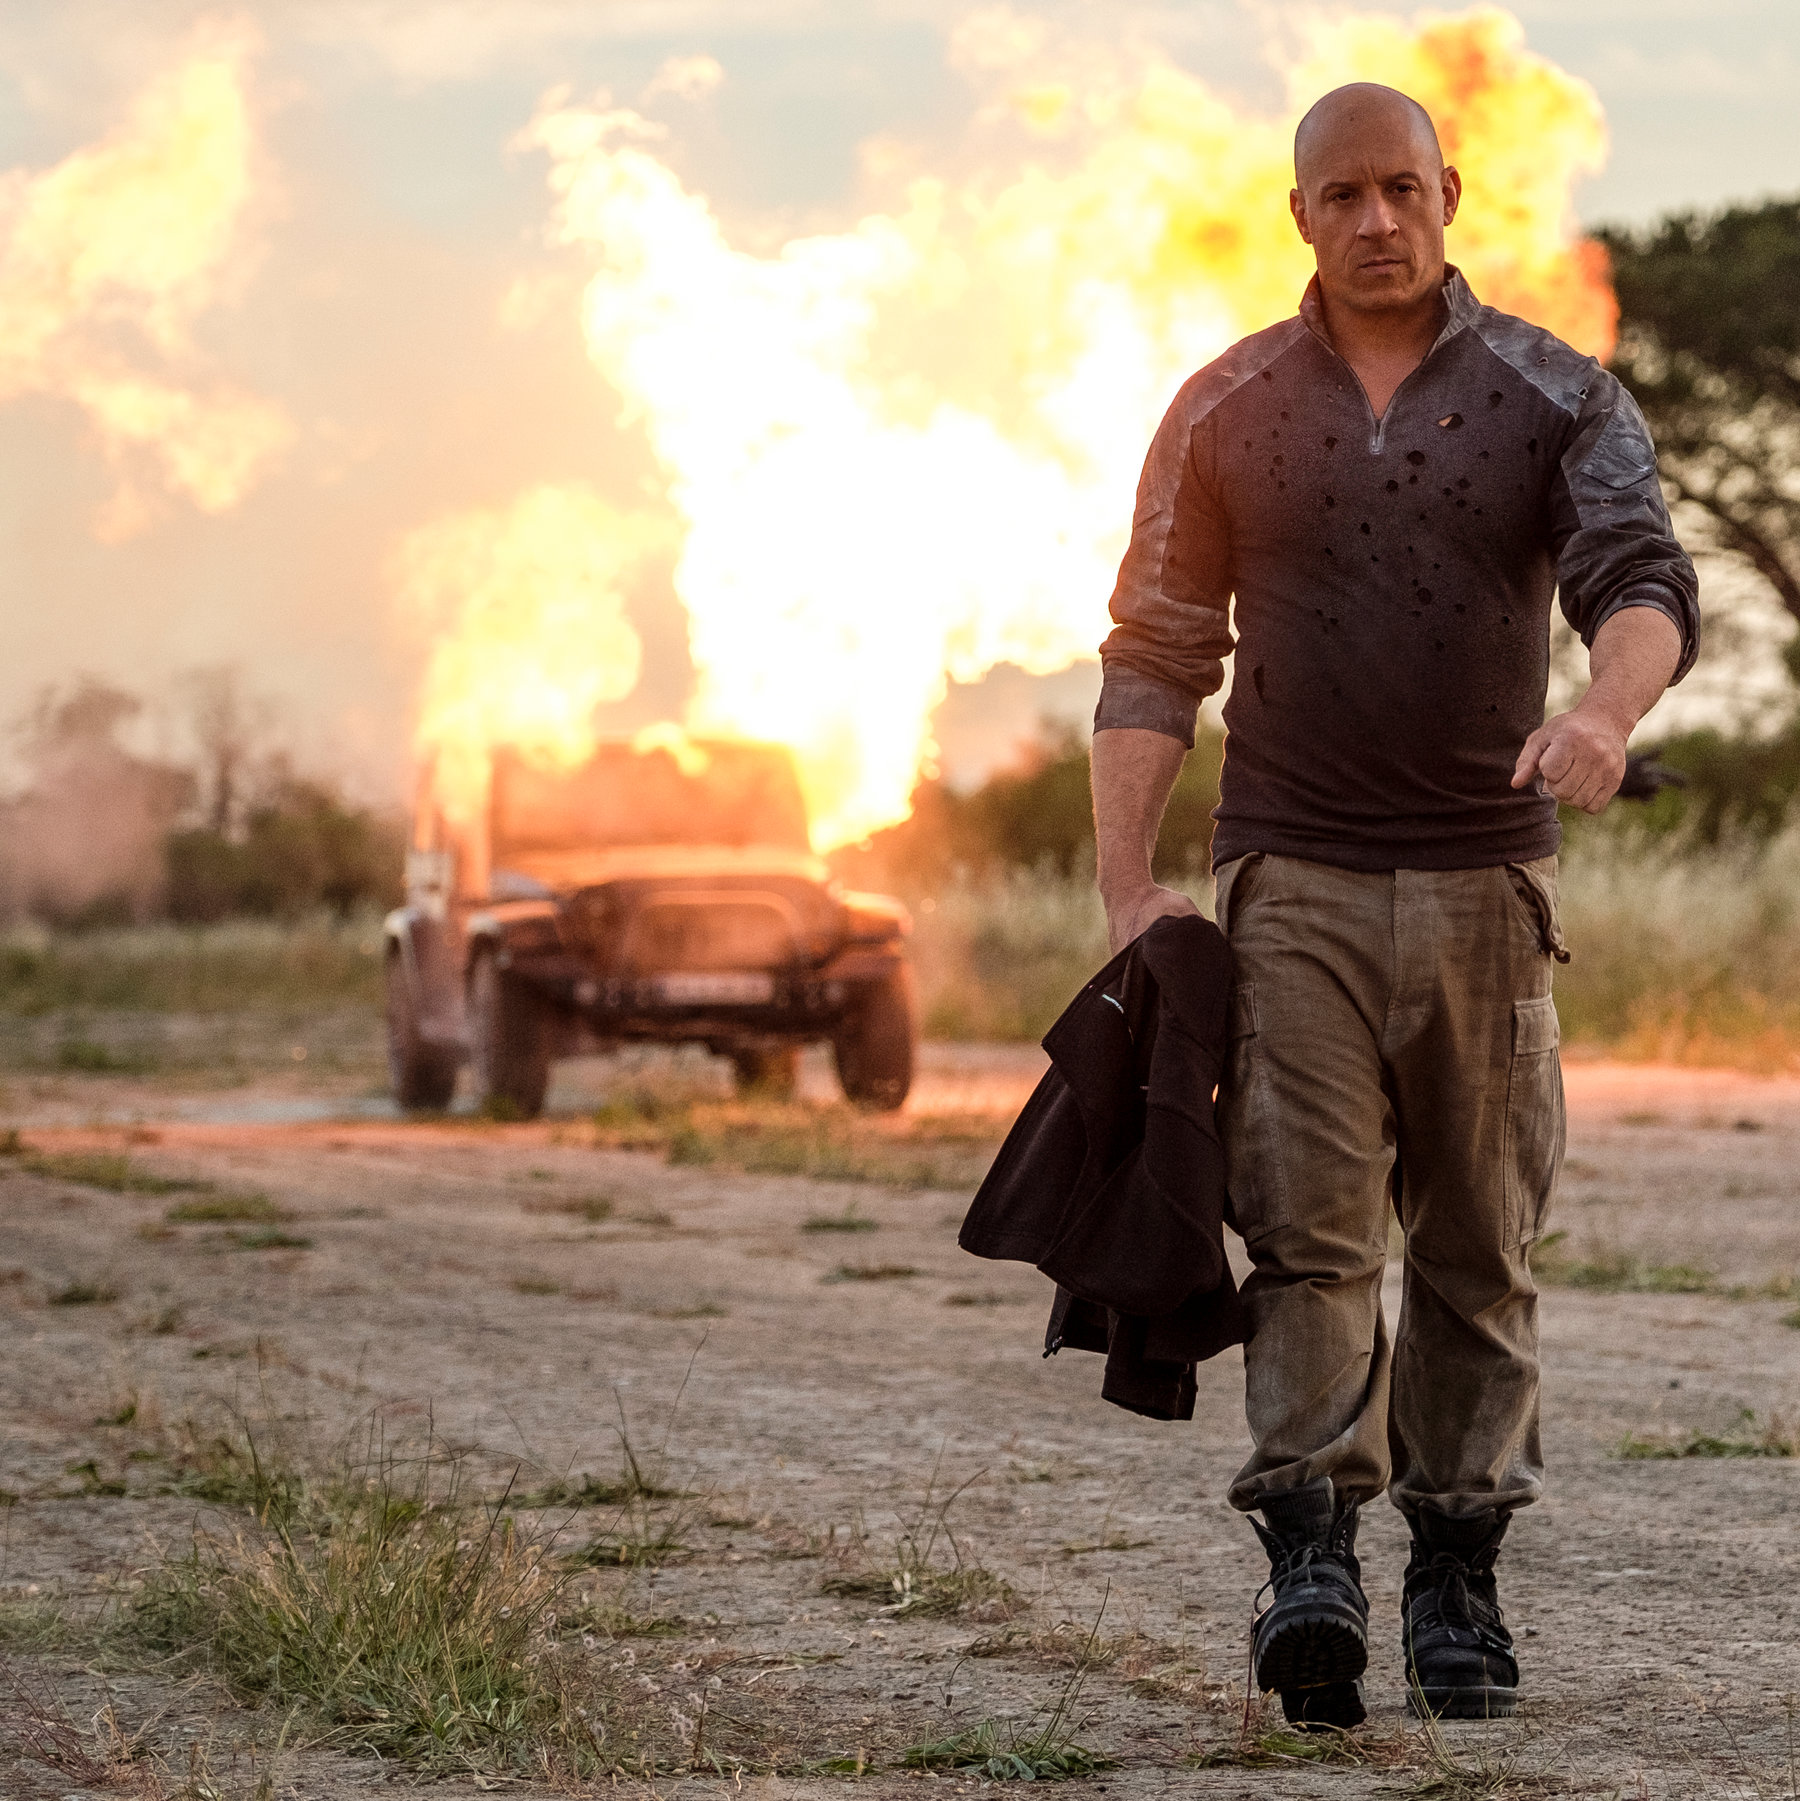What's happening in the scene?
 In the image, the renowned actor Vin Diesel is captured in a dramatic scene. He is seen striding away from a fiery explosion, his back to the camera. Dressed in a gray shirt speckled with black spots, beige pants, and black shoes, he exudes an air of nonchalance despite the chaos behind him. In his left hand, he casually carries a black jacket.

The explosion is erupting behind a black car parked on a dirt road, sending bright orange and red flames into the air. The sky above is painted in hues of orange, suggesting that the scene is set at sunset. The surrounding grass is tinged with brown, further enhancing the warm color palette of the image.

Despite the explosive backdrop, Vin Diesel's calm demeanor and steady gait lend a stark contrast to the scene, embodying the fearless persona often associated with his characters. 